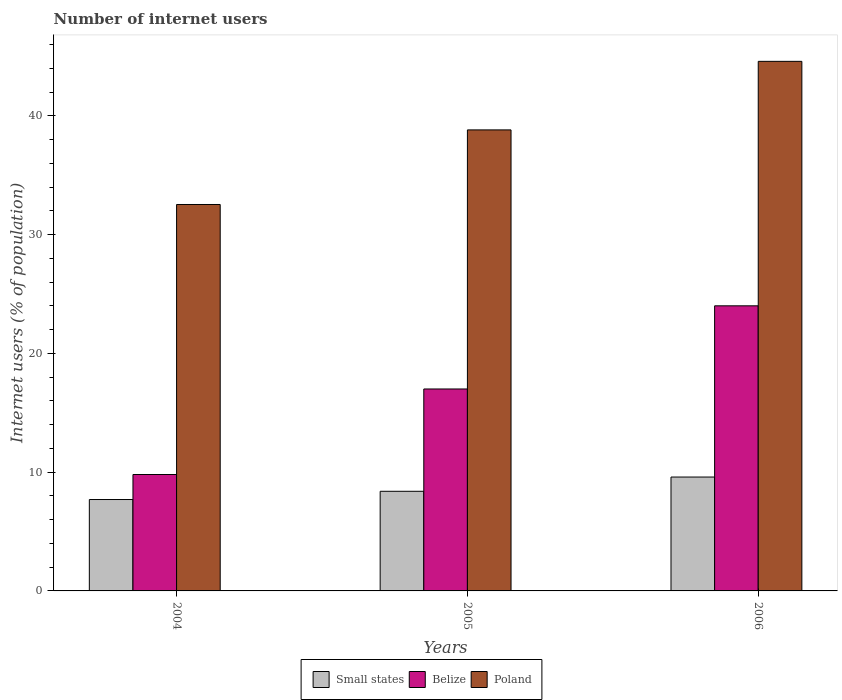How many different coloured bars are there?
Your answer should be very brief. 3. Are the number of bars per tick equal to the number of legend labels?
Give a very brief answer. Yes. In how many cases, is the number of bars for a given year not equal to the number of legend labels?
Your response must be concise. 0. What is the number of internet users in Small states in 2005?
Offer a very short reply. 8.39. Across all years, what is the maximum number of internet users in Poland?
Provide a short and direct response. 44.58. Across all years, what is the minimum number of internet users in Belize?
Provide a succinct answer. 9.8. In which year was the number of internet users in Small states minimum?
Ensure brevity in your answer.  2004. What is the total number of internet users in Belize in the graph?
Provide a succinct answer. 50.8. What is the difference between the number of internet users in Small states in 2004 and that in 2005?
Ensure brevity in your answer.  -0.69. What is the difference between the number of internet users in Poland in 2005 and the number of internet users in Small states in 2006?
Ensure brevity in your answer.  29.22. What is the average number of internet users in Small states per year?
Offer a very short reply. 8.56. In the year 2004, what is the difference between the number of internet users in Poland and number of internet users in Belize?
Offer a terse response. 22.73. In how many years, is the number of internet users in Belize greater than 32 %?
Make the answer very short. 0. What is the ratio of the number of internet users in Poland in 2004 to that in 2006?
Give a very brief answer. 0.73. Is the number of internet users in Poland in 2004 less than that in 2005?
Offer a very short reply. Yes. What is the difference between the highest and the lowest number of internet users in Belize?
Keep it short and to the point. 14.2. In how many years, is the number of internet users in Poland greater than the average number of internet users in Poland taken over all years?
Your answer should be very brief. 2. Is the sum of the number of internet users in Belize in 2004 and 2006 greater than the maximum number of internet users in Poland across all years?
Ensure brevity in your answer.  No. What does the 1st bar from the left in 2006 represents?
Make the answer very short. Small states. Is it the case that in every year, the sum of the number of internet users in Poland and number of internet users in Belize is greater than the number of internet users in Small states?
Give a very brief answer. Yes. How many years are there in the graph?
Ensure brevity in your answer.  3. Does the graph contain any zero values?
Give a very brief answer. No. Does the graph contain grids?
Keep it short and to the point. No. Where does the legend appear in the graph?
Make the answer very short. Bottom center. How many legend labels are there?
Your answer should be compact. 3. How are the legend labels stacked?
Provide a succinct answer. Horizontal. What is the title of the graph?
Give a very brief answer. Number of internet users. Does "Greece" appear as one of the legend labels in the graph?
Keep it short and to the point. No. What is the label or title of the Y-axis?
Provide a short and direct response. Internet users (% of population). What is the Internet users (% of population) of Small states in 2004?
Give a very brief answer. 7.69. What is the Internet users (% of population) of Belize in 2004?
Provide a succinct answer. 9.8. What is the Internet users (% of population) of Poland in 2004?
Give a very brief answer. 32.53. What is the Internet users (% of population) in Small states in 2005?
Ensure brevity in your answer.  8.39. What is the Internet users (% of population) in Belize in 2005?
Provide a short and direct response. 17. What is the Internet users (% of population) of Poland in 2005?
Make the answer very short. 38.81. What is the Internet users (% of population) of Small states in 2006?
Offer a very short reply. 9.59. What is the Internet users (% of population) of Poland in 2006?
Provide a short and direct response. 44.58. Across all years, what is the maximum Internet users (% of population) in Small states?
Your answer should be very brief. 9.59. Across all years, what is the maximum Internet users (% of population) of Belize?
Ensure brevity in your answer.  24. Across all years, what is the maximum Internet users (% of population) of Poland?
Offer a very short reply. 44.58. Across all years, what is the minimum Internet users (% of population) in Small states?
Your answer should be compact. 7.69. Across all years, what is the minimum Internet users (% of population) in Belize?
Ensure brevity in your answer.  9.8. Across all years, what is the minimum Internet users (% of population) in Poland?
Keep it short and to the point. 32.53. What is the total Internet users (% of population) in Small states in the graph?
Your response must be concise. 25.67. What is the total Internet users (% of population) of Belize in the graph?
Your response must be concise. 50.8. What is the total Internet users (% of population) in Poland in the graph?
Provide a succinct answer. 115.92. What is the difference between the Internet users (% of population) of Small states in 2004 and that in 2005?
Give a very brief answer. -0.69. What is the difference between the Internet users (% of population) in Belize in 2004 and that in 2005?
Your answer should be compact. -7.2. What is the difference between the Internet users (% of population) in Poland in 2004 and that in 2005?
Provide a short and direct response. -6.28. What is the difference between the Internet users (% of population) of Small states in 2004 and that in 2006?
Ensure brevity in your answer.  -1.89. What is the difference between the Internet users (% of population) of Poland in 2004 and that in 2006?
Keep it short and to the point. -12.05. What is the difference between the Internet users (% of population) of Small states in 2005 and that in 2006?
Your answer should be very brief. -1.2. What is the difference between the Internet users (% of population) in Belize in 2005 and that in 2006?
Keep it short and to the point. -7. What is the difference between the Internet users (% of population) of Poland in 2005 and that in 2006?
Your response must be concise. -5.77. What is the difference between the Internet users (% of population) of Small states in 2004 and the Internet users (% of population) of Belize in 2005?
Offer a terse response. -9.31. What is the difference between the Internet users (% of population) in Small states in 2004 and the Internet users (% of population) in Poland in 2005?
Offer a very short reply. -31.12. What is the difference between the Internet users (% of population) in Belize in 2004 and the Internet users (% of population) in Poland in 2005?
Offer a very short reply. -29.01. What is the difference between the Internet users (% of population) in Small states in 2004 and the Internet users (% of population) in Belize in 2006?
Make the answer very short. -16.31. What is the difference between the Internet users (% of population) of Small states in 2004 and the Internet users (% of population) of Poland in 2006?
Your response must be concise. -36.89. What is the difference between the Internet users (% of population) in Belize in 2004 and the Internet users (% of population) in Poland in 2006?
Provide a short and direct response. -34.78. What is the difference between the Internet users (% of population) of Small states in 2005 and the Internet users (% of population) of Belize in 2006?
Offer a very short reply. -15.61. What is the difference between the Internet users (% of population) of Small states in 2005 and the Internet users (% of population) of Poland in 2006?
Offer a terse response. -36.19. What is the difference between the Internet users (% of population) of Belize in 2005 and the Internet users (% of population) of Poland in 2006?
Offer a very short reply. -27.58. What is the average Internet users (% of population) in Small states per year?
Your response must be concise. 8.56. What is the average Internet users (% of population) of Belize per year?
Your response must be concise. 16.93. What is the average Internet users (% of population) of Poland per year?
Keep it short and to the point. 38.64. In the year 2004, what is the difference between the Internet users (% of population) in Small states and Internet users (% of population) in Belize?
Your answer should be very brief. -2.11. In the year 2004, what is the difference between the Internet users (% of population) in Small states and Internet users (% of population) in Poland?
Give a very brief answer. -24.84. In the year 2004, what is the difference between the Internet users (% of population) in Belize and Internet users (% of population) in Poland?
Give a very brief answer. -22.73. In the year 2005, what is the difference between the Internet users (% of population) in Small states and Internet users (% of population) in Belize?
Provide a succinct answer. -8.61. In the year 2005, what is the difference between the Internet users (% of population) of Small states and Internet users (% of population) of Poland?
Keep it short and to the point. -30.42. In the year 2005, what is the difference between the Internet users (% of population) in Belize and Internet users (% of population) in Poland?
Your response must be concise. -21.81. In the year 2006, what is the difference between the Internet users (% of population) in Small states and Internet users (% of population) in Belize?
Your response must be concise. -14.41. In the year 2006, what is the difference between the Internet users (% of population) of Small states and Internet users (% of population) of Poland?
Your answer should be compact. -34.99. In the year 2006, what is the difference between the Internet users (% of population) in Belize and Internet users (% of population) in Poland?
Give a very brief answer. -20.58. What is the ratio of the Internet users (% of population) of Small states in 2004 to that in 2005?
Provide a succinct answer. 0.92. What is the ratio of the Internet users (% of population) in Belize in 2004 to that in 2005?
Offer a terse response. 0.58. What is the ratio of the Internet users (% of population) in Poland in 2004 to that in 2005?
Make the answer very short. 0.84. What is the ratio of the Internet users (% of population) in Small states in 2004 to that in 2006?
Give a very brief answer. 0.8. What is the ratio of the Internet users (% of population) of Belize in 2004 to that in 2006?
Provide a succinct answer. 0.41. What is the ratio of the Internet users (% of population) in Poland in 2004 to that in 2006?
Ensure brevity in your answer.  0.73. What is the ratio of the Internet users (% of population) of Small states in 2005 to that in 2006?
Make the answer very short. 0.87. What is the ratio of the Internet users (% of population) in Belize in 2005 to that in 2006?
Offer a very short reply. 0.71. What is the ratio of the Internet users (% of population) in Poland in 2005 to that in 2006?
Provide a succinct answer. 0.87. What is the difference between the highest and the second highest Internet users (% of population) in Small states?
Ensure brevity in your answer.  1.2. What is the difference between the highest and the second highest Internet users (% of population) of Poland?
Offer a terse response. 5.77. What is the difference between the highest and the lowest Internet users (% of population) of Small states?
Your answer should be very brief. 1.89. What is the difference between the highest and the lowest Internet users (% of population) of Belize?
Keep it short and to the point. 14.2. What is the difference between the highest and the lowest Internet users (% of population) of Poland?
Your answer should be very brief. 12.05. 